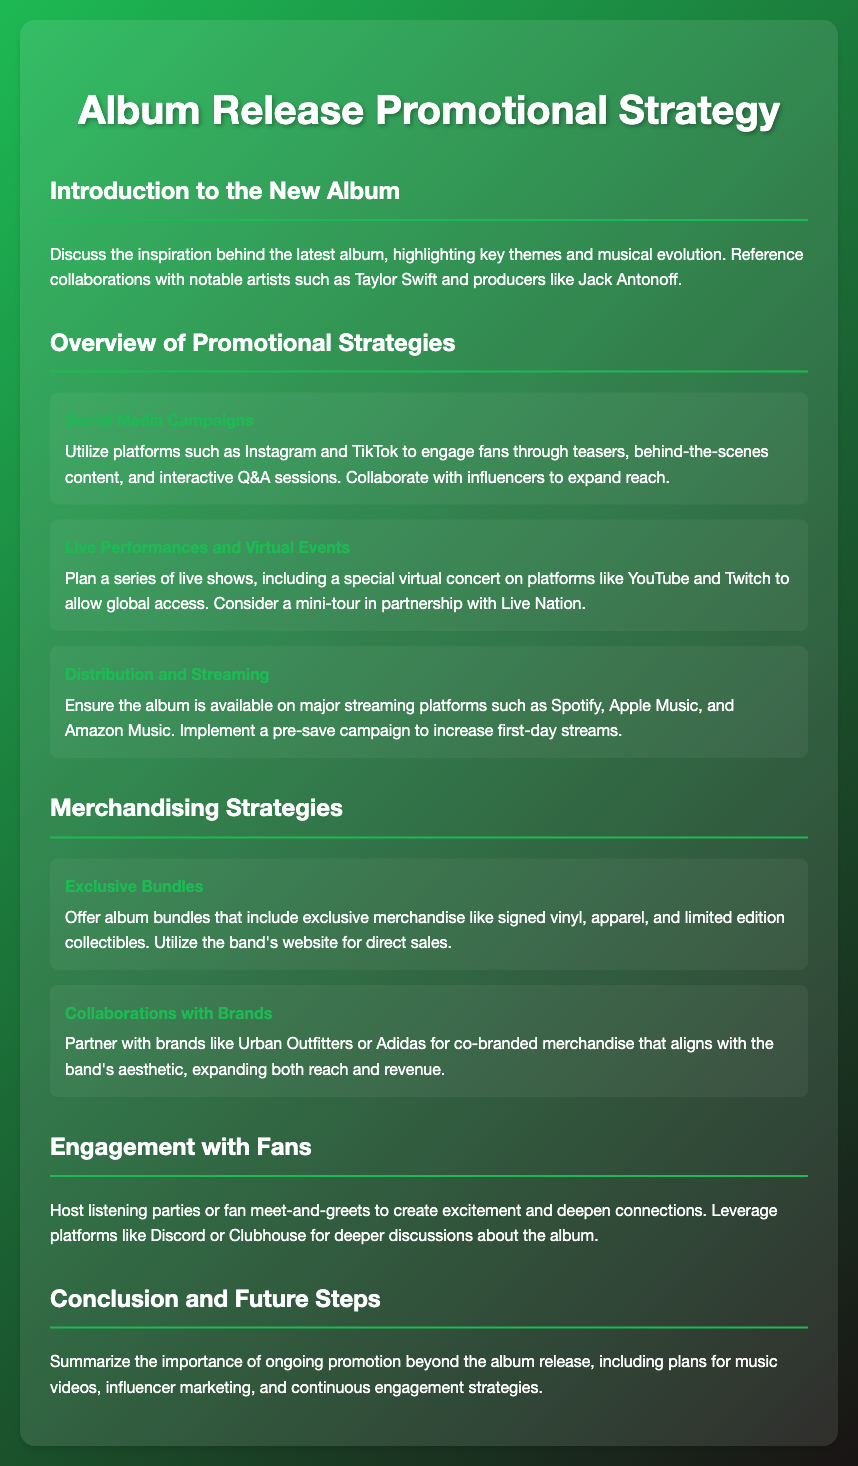What is the title of the document? The title of the document is displayed prominently at the top, indicating the focus of the content.
Answer: Album Release Promotional Strategy Who are the notable collaborators mentioned for the album? The document highlights specific well-known artists and producers who contributed to the album.
Answer: Taylor Swift and Jack Antonoff What platforms are mentioned for the live performances? The document refers to specific platforms where virtual concerts can take place, indicating the scope of engagement.
Answer: YouTube and Twitch What type of merchandise is offered as exclusive bundles? The document specifies the type of items included in the exclusive bundles available for fans.
Answer: Signed vinyl, apparel, and limited edition collectibles Which brands are suggested for merchandise collaborations? The document lists specific brands with whom the promotion and merchandise strategies could align.
Answer: Urban Outfitters and Adidas What is one key aspect of the social media campaign? The document emphasizes a particular method utilized within the campaign strategies that help in fan engagement.
Answer: Influencer collaboration How many streaming platforms are mentioned for distribution? The document references certain platforms where the album will be made available, illustrating the distribution strategy.
Answer: Three What is suggested for increasing first-day streams of the album? The document suggests an action that can be taken prior to the album release to boost initial listener numbers.
Answer: Pre-save campaign What is one method mentioned to engage fans? The document provides an example of an interactive event that can be hosted to connect with fans following the release.
Answer: Listening parties 